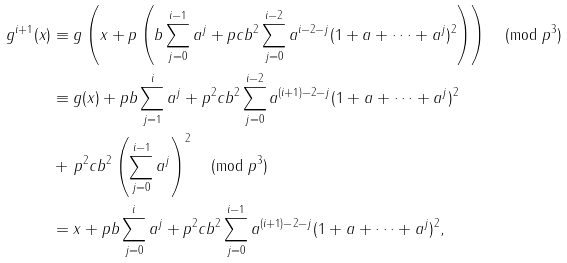Convert formula to latex. <formula><loc_0><loc_0><loc_500><loc_500>g ^ { i + 1 } ( x ) & \equiv g \left ( x + p \left ( b \sum _ { j = 0 } ^ { i - 1 } a ^ { j } + p c b ^ { 2 } \sum _ { j = 0 } ^ { i - 2 } a ^ { i - 2 - j } ( 1 + a + \dots + a ^ { j } ) ^ { 2 } \right ) \right ) \pmod { p ^ { 3 } } \\ & \equiv g ( x ) + p b \sum _ { j = 1 } ^ { i } a ^ { j } + p ^ { 2 } c b ^ { 2 } \sum _ { j = 0 } ^ { i - 2 } a ^ { ( i + 1 ) - 2 - j } ( 1 + a + \dots + a ^ { j } ) ^ { 2 } \\ & + \, p ^ { 2 } c b ^ { 2 } \left ( \sum _ { j = 0 } ^ { i - 1 } a ^ { j } \right ) ^ { 2 } \pmod { p ^ { 3 } } \\ & = x + p b \sum _ { j = 0 } ^ { i } a ^ { j } + p ^ { 2 } c b ^ { 2 } \sum _ { j = 0 } ^ { i - 1 } a ^ { ( i + 1 ) - 2 - j } ( 1 + a + \dots + a ^ { j } ) ^ { 2 } ,</formula> 